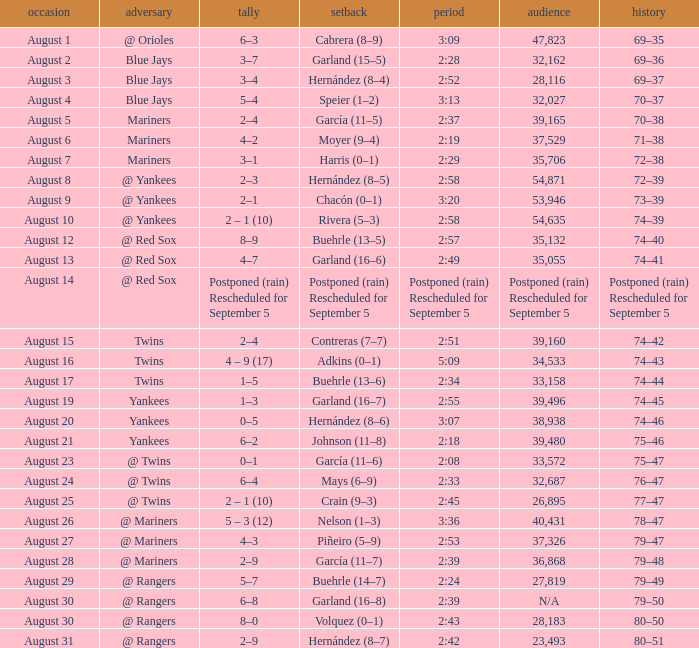Who lost on August 27? Piñeiro (5–9). 